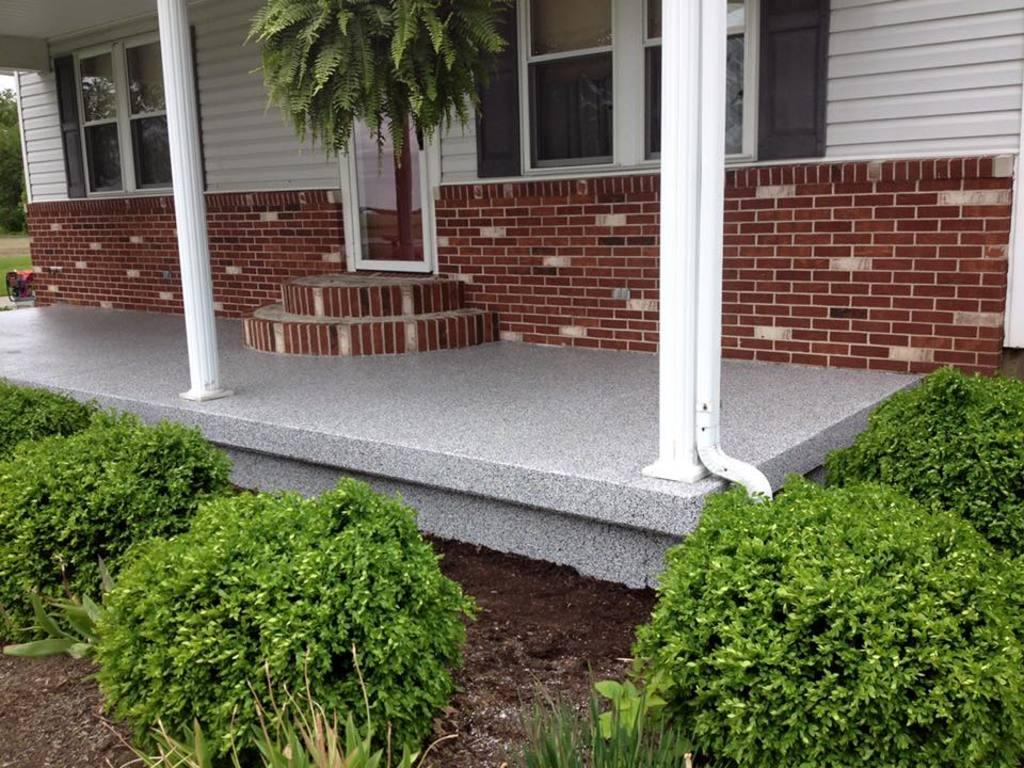What is located at the bottom side of the image? There are plants at the bottom side of the image. What is the main structure in the image? There is a house in the center of the image. What feature of the house can be seen in the image? The house has windows. What type of environment is visible in the background of the image? There is greenery in the background of the image. What shape is the ground in the image? There is no ground present in the image; it features plants, a house, and greenery in the background. Where is the camp located in the image? There is no camp present in the image. 